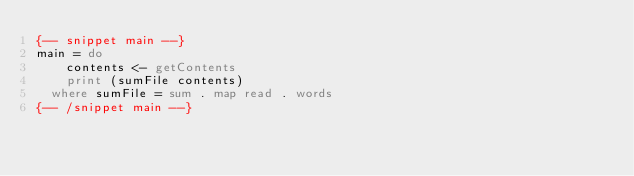Convert code to text. <code><loc_0><loc_0><loc_500><loc_500><_Haskell_>{-- snippet main --}
main = do
    contents <- getContents
    print (sumFile contents)
  where sumFile = sum . map read . words
{-- /snippet main --}
</code> 